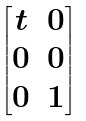<formula> <loc_0><loc_0><loc_500><loc_500>\begin{bmatrix} t & 0 \\ 0 & 0 \\ 0 & 1 \end{bmatrix}</formula> 